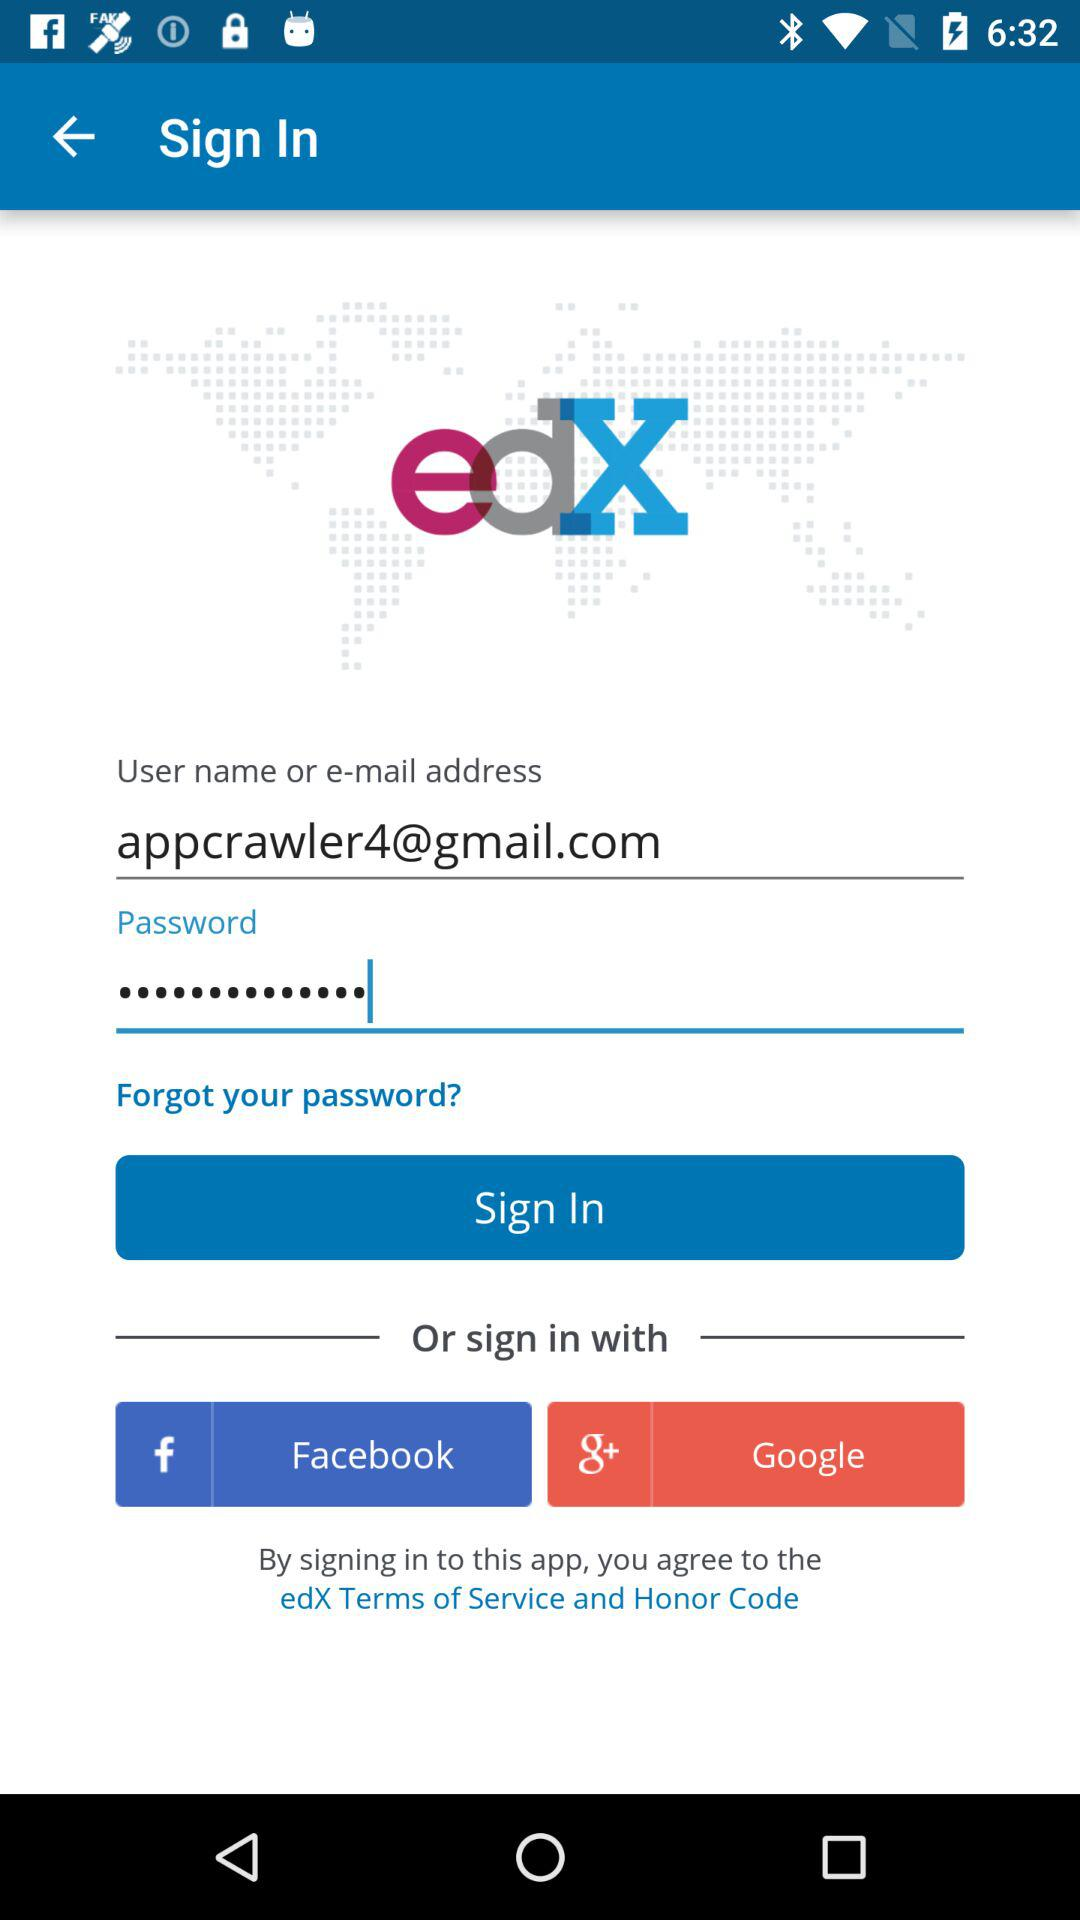Which are the different options to sign in? The different options to sign in are "Facebook" and "Google". 